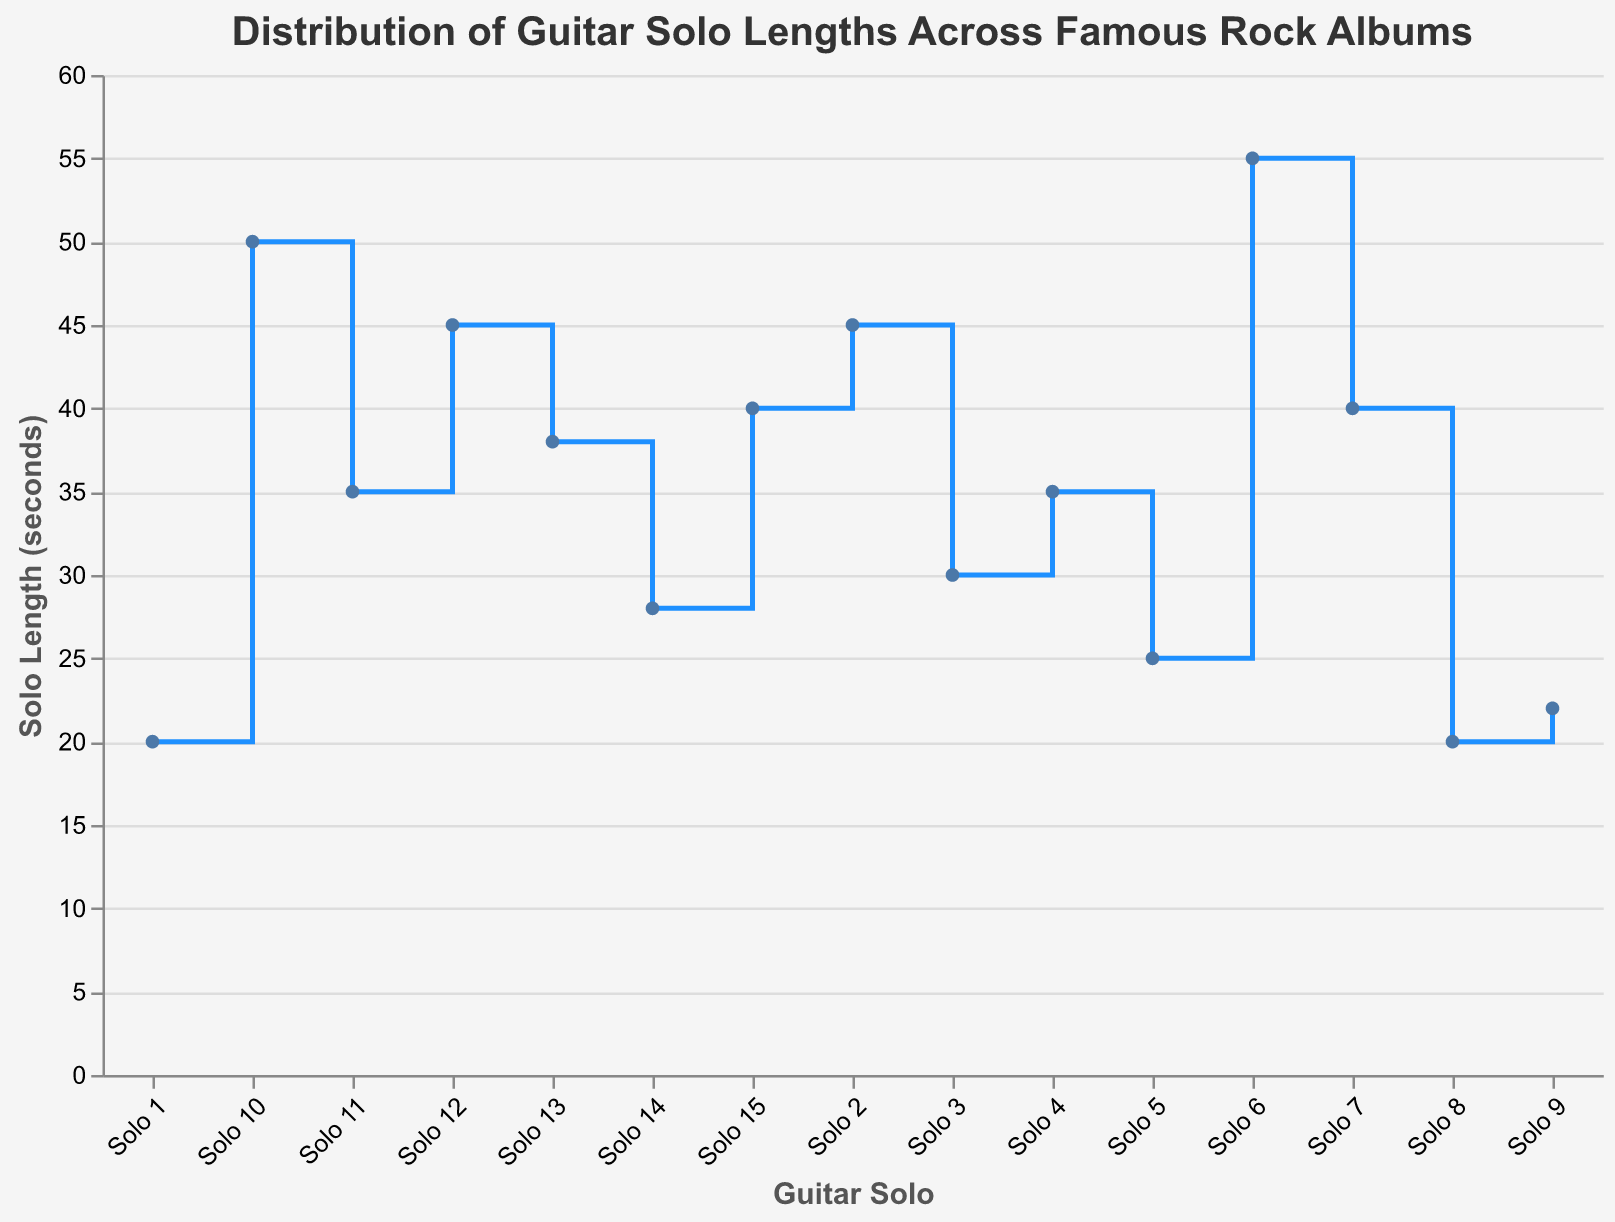How many guitar solos' lengths are displayed on the plot? Each point on the line plot represents a guitar solo. By counting the points, we can see the total number of guitar solos.
Answer: 15 Which guitar solo has the longest length and what is it? Identify the highest point on the y-axis from the stair steps. This point corresponds to the longest guitar solo.
Answer: Hotel California, 55 seconds Is there more than one guitar solo with the same length? If yes, how many such pairs exist? Check each stair step to find steps with the same y-value. Solo 1 (Dark Side of the Moon) and Solo 8 (Abbey Road) both have lengths of 20 seconds. Therefore, there is one repeated length.
Answer: Yes, 1 pair What is the median length of all the guitar solos? Arrange the solo lengths in ascending order: [20, 20, 22, 25, 28, 30, 35, 35, 38, 40, 40, 45, 45, 50, 55]. The median is the middle value (8th value in this case), which is 35 seconds.
Answer: 35 Compare the length of the guitar solos for 'Electric Ladyland' and 'Led Zeppelin IV'. Which one is longer and by how much? Find the lengths for 'Electric Ladyland' (50 seconds) and 'Led Zeppelin IV' (45 seconds). Subtract the shorter from the longer.
Answer: Electric Ladyland is longer by 5 seconds Which intervals show the steepest increase in guitar solo length? The steepest increase happens where the step height is the greatest. Look for the largest vertical movement between two consecutive points. The jump from The Wall (25 seconds) to Hotel California (55 seconds) is the steepest.
Answer: Between The Wall and Hotel California What are the solo lengths for the guitarist David Gilmour and how do they vary? Identify the points corresponding to David Gilmour's solos and list their lengths: Solo 1 (20 seconds) and Solo 5 (25 seconds).
Answer: 20 and 25 seconds How does the length of Joe Walsh’s solo compare to the average length of all solos? Joe Walsh's solo is 55 seconds. Calculate the average by summing all the lengths and dividing by the number of solos: (20+45+30+35+25+55+40+20+22+50+35+45+38+28+40) / 15 = 36.67 seconds.
Answer: Joe Walsh's solo is longer by 18.33 seconds Among the solos with lengths between 30 and 40 seconds, how many solos fall into this range? Count the number of solos within the range of 30 to 40 seconds, inclusive: Solos 3, 4, 7, 11, and 13.
Answer: 5 